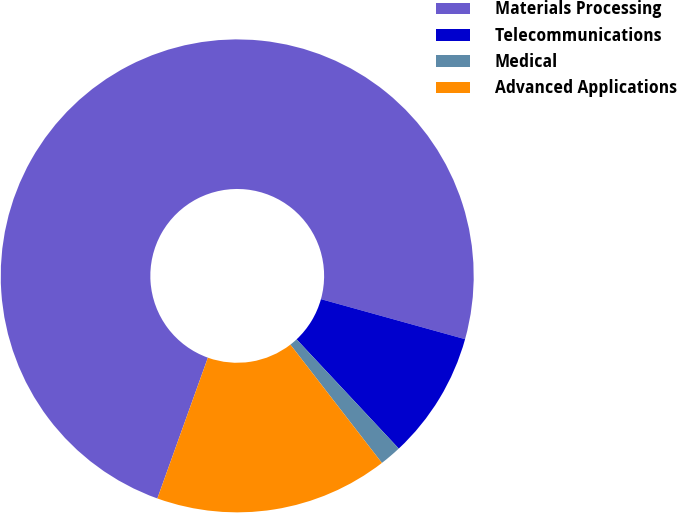<chart> <loc_0><loc_0><loc_500><loc_500><pie_chart><fcel>Materials Processing<fcel>Telecommunications<fcel>Medical<fcel>Advanced Applications<nl><fcel>73.83%<fcel>8.72%<fcel>1.49%<fcel>15.96%<nl></chart> 